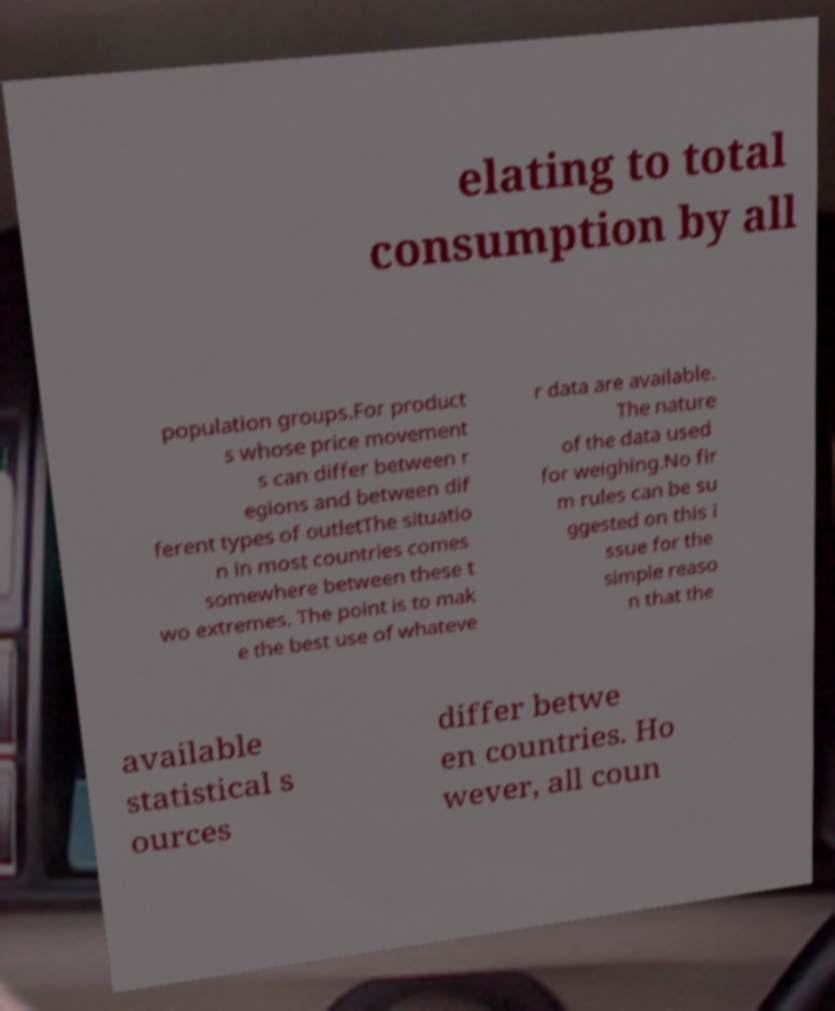Could you extract and type out the text from this image? elating to total consumption by all population groups.For product s whose price movement s can differ between r egions and between dif ferent types of outletThe situatio n in most countries comes somewhere between these t wo extremes. The point is to mak e the best use of whateve r data are available. The nature of the data used for weighing.No fir m rules can be su ggested on this i ssue for the simple reaso n that the available statistical s ources differ betwe en countries. Ho wever, all coun 